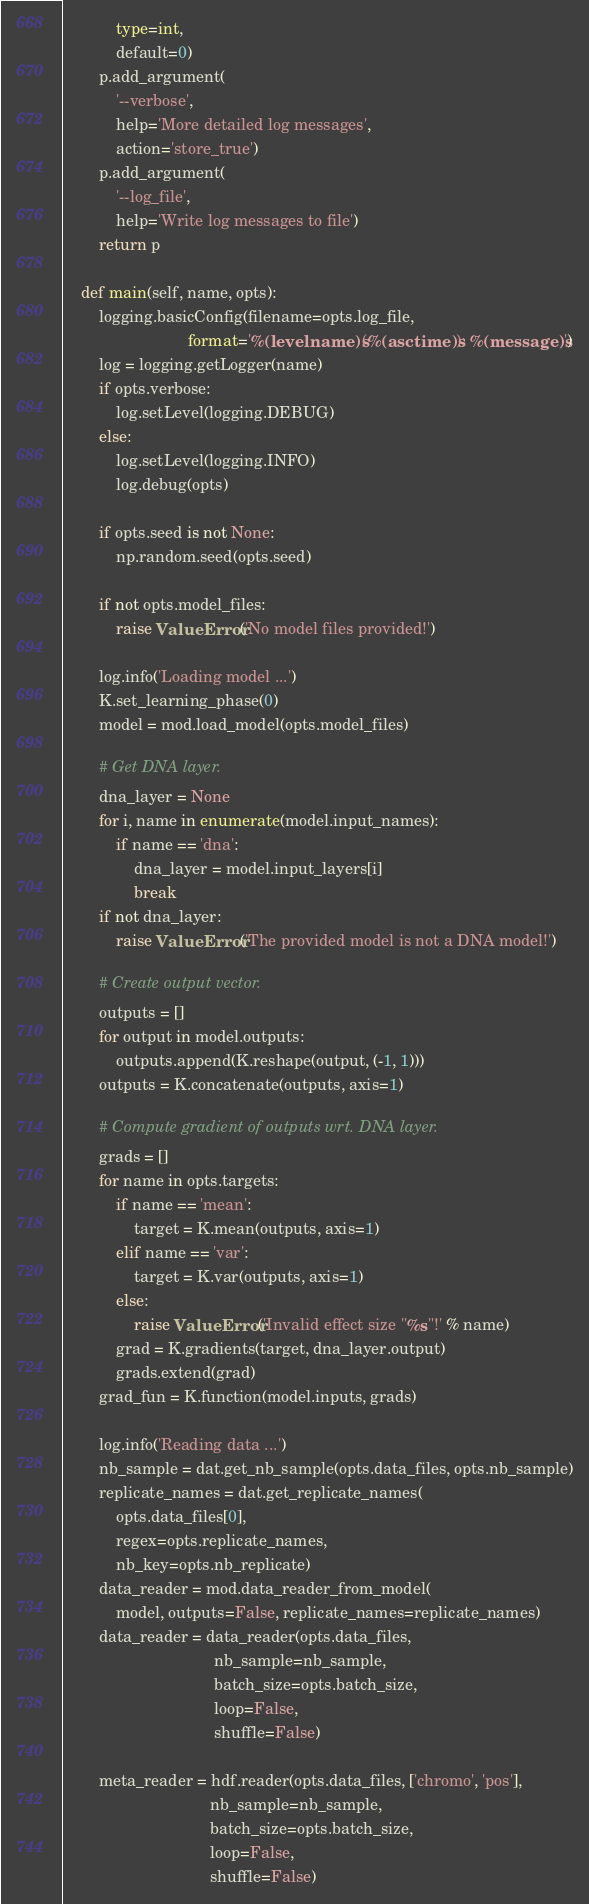<code> <loc_0><loc_0><loc_500><loc_500><_Python_>            type=int,
            default=0)
        p.add_argument(
            '--verbose',
            help='More detailed log messages',
            action='store_true')
        p.add_argument(
            '--log_file',
            help='Write log messages to file')
        return p

    def main(self, name, opts):
        logging.basicConfig(filename=opts.log_file,
                            format='%(levelname)s (%(asctime)s): %(message)s')
        log = logging.getLogger(name)
        if opts.verbose:
            log.setLevel(logging.DEBUG)
        else:
            log.setLevel(logging.INFO)
            log.debug(opts)

        if opts.seed is not None:
            np.random.seed(opts.seed)

        if not opts.model_files:
            raise ValueError('No model files provided!')

        log.info('Loading model ...')
        K.set_learning_phase(0)
        model = mod.load_model(opts.model_files)

        # Get DNA layer.
        dna_layer = None
        for i, name in enumerate(model.input_names):
            if name == 'dna':
                dna_layer = model.input_layers[i]
                break
        if not dna_layer:
            raise ValueError('The provided model is not a DNA model!')

        # Create output vector.
        outputs = []
        for output in model.outputs:
            outputs.append(K.reshape(output, (-1, 1)))
        outputs = K.concatenate(outputs, axis=1)

        # Compute gradient of outputs wrt. DNA layer.
        grads = []
        for name in opts.targets:
            if name == 'mean':
                target = K.mean(outputs, axis=1)
            elif name == 'var':
                target = K.var(outputs, axis=1)
            else:
                raise ValueError('Invalid effect size "%s"!' % name)
            grad = K.gradients(target, dna_layer.output)
            grads.extend(grad)
        grad_fun = K.function(model.inputs, grads)

        log.info('Reading data ...')
        nb_sample = dat.get_nb_sample(opts.data_files, opts.nb_sample)
        replicate_names = dat.get_replicate_names(
            opts.data_files[0],
            regex=opts.replicate_names,
            nb_key=opts.nb_replicate)
        data_reader = mod.data_reader_from_model(
            model, outputs=False, replicate_names=replicate_names)
        data_reader = data_reader(opts.data_files,
                                  nb_sample=nb_sample,
                                  batch_size=opts.batch_size,
                                  loop=False,
                                  shuffle=False)

        meta_reader = hdf.reader(opts.data_files, ['chromo', 'pos'],
                                 nb_sample=nb_sample,
                                 batch_size=opts.batch_size,
                                 loop=False,
                                 shuffle=False)
</code> 